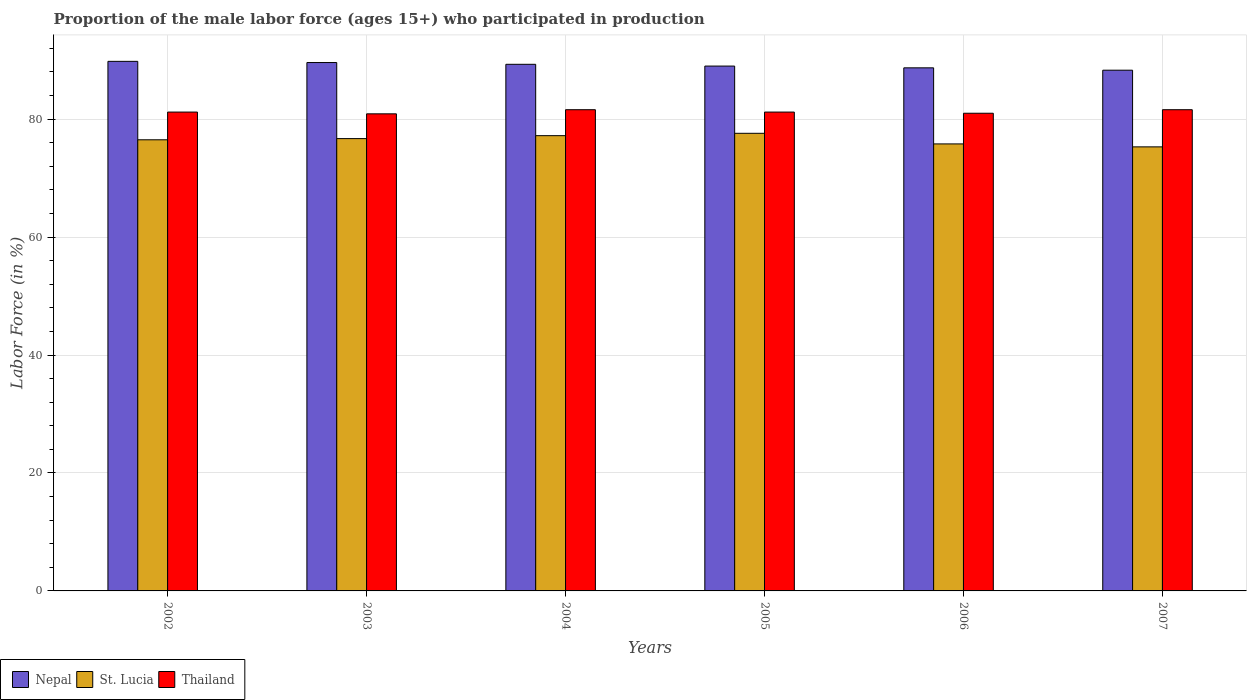How many bars are there on the 4th tick from the right?
Give a very brief answer. 3. In how many cases, is the number of bars for a given year not equal to the number of legend labels?
Keep it short and to the point. 0. What is the proportion of the male labor force who participated in production in St. Lucia in 2006?
Make the answer very short. 75.8. Across all years, what is the maximum proportion of the male labor force who participated in production in Thailand?
Make the answer very short. 81.6. Across all years, what is the minimum proportion of the male labor force who participated in production in Nepal?
Keep it short and to the point. 88.3. In which year was the proportion of the male labor force who participated in production in Thailand maximum?
Offer a terse response. 2004. What is the total proportion of the male labor force who participated in production in Thailand in the graph?
Keep it short and to the point. 487.5. What is the difference between the proportion of the male labor force who participated in production in St. Lucia in 2004 and that in 2007?
Provide a short and direct response. 1.9. What is the difference between the proportion of the male labor force who participated in production in Thailand in 2003 and the proportion of the male labor force who participated in production in St. Lucia in 2005?
Give a very brief answer. 3.3. What is the average proportion of the male labor force who participated in production in Thailand per year?
Ensure brevity in your answer.  81.25. In the year 2004, what is the difference between the proportion of the male labor force who participated in production in Nepal and proportion of the male labor force who participated in production in St. Lucia?
Your answer should be very brief. 12.1. In how many years, is the proportion of the male labor force who participated in production in Thailand greater than 24 %?
Provide a short and direct response. 6. What is the ratio of the proportion of the male labor force who participated in production in St. Lucia in 2002 to that in 2003?
Provide a succinct answer. 1. Is the proportion of the male labor force who participated in production in Nepal in 2006 less than that in 2007?
Ensure brevity in your answer.  No. What is the difference between the highest and the second highest proportion of the male labor force who participated in production in Thailand?
Your answer should be very brief. 0. What is the difference between the highest and the lowest proportion of the male labor force who participated in production in Thailand?
Provide a short and direct response. 0.7. Is the sum of the proportion of the male labor force who participated in production in Nepal in 2003 and 2004 greater than the maximum proportion of the male labor force who participated in production in St. Lucia across all years?
Provide a short and direct response. Yes. What does the 1st bar from the left in 2003 represents?
Your answer should be very brief. Nepal. What does the 3rd bar from the right in 2005 represents?
Provide a succinct answer. Nepal. Are all the bars in the graph horizontal?
Give a very brief answer. No. What is the difference between two consecutive major ticks on the Y-axis?
Your answer should be very brief. 20. Where does the legend appear in the graph?
Offer a very short reply. Bottom left. What is the title of the graph?
Make the answer very short. Proportion of the male labor force (ages 15+) who participated in production. Does "Spain" appear as one of the legend labels in the graph?
Your answer should be very brief. No. What is the label or title of the Y-axis?
Ensure brevity in your answer.  Labor Force (in %). What is the Labor Force (in %) in Nepal in 2002?
Offer a very short reply. 89.8. What is the Labor Force (in %) of St. Lucia in 2002?
Your answer should be very brief. 76.5. What is the Labor Force (in %) of Thailand in 2002?
Provide a short and direct response. 81.2. What is the Labor Force (in %) of Nepal in 2003?
Keep it short and to the point. 89.6. What is the Labor Force (in %) of St. Lucia in 2003?
Offer a very short reply. 76.7. What is the Labor Force (in %) of Thailand in 2003?
Ensure brevity in your answer.  80.9. What is the Labor Force (in %) in Nepal in 2004?
Ensure brevity in your answer.  89.3. What is the Labor Force (in %) in St. Lucia in 2004?
Provide a short and direct response. 77.2. What is the Labor Force (in %) in Thailand in 2004?
Your answer should be compact. 81.6. What is the Labor Force (in %) in Nepal in 2005?
Your response must be concise. 89. What is the Labor Force (in %) of St. Lucia in 2005?
Provide a short and direct response. 77.6. What is the Labor Force (in %) in Thailand in 2005?
Your answer should be very brief. 81.2. What is the Labor Force (in %) in Nepal in 2006?
Provide a short and direct response. 88.7. What is the Labor Force (in %) in St. Lucia in 2006?
Ensure brevity in your answer.  75.8. What is the Labor Force (in %) of Nepal in 2007?
Your answer should be compact. 88.3. What is the Labor Force (in %) of St. Lucia in 2007?
Keep it short and to the point. 75.3. What is the Labor Force (in %) in Thailand in 2007?
Give a very brief answer. 81.6. Across all years, what is the maximum Labor Force (in %) in Nepal?
Keep it short and to the point. 89.8. Across all years, what is the maximum Labor Force (in %) in St. Lucia?
Your answer should be compact. 77.6. Across all years, what is the maximum Labor Force (in %) of Thailand?
Give a very brief answer. 81.6. Across all years, what is the minimum Labor Force (in %) of Nepal?
Provide a succinct answer. 88.3. Across all years, what is the minimum Labor Force (in %) of St. Lucia?
Your answer should be compact. 75.3. Across all years, what is the minimum Labor Force (in %) of Thailand?
Provide a short and direct response. 80.9. What is the total Labor Force (in %) of Nepal in the graph?
Your response must be concise. 534.7. What is the total Labor Force (in %) of St. Lucia in the graph?
Ensure brevity in your answer.  459.1. What is the total Labor Force (in %) in Thailand in the graph?
Provide a succinct answer. 487.5. What is the difference between the Labor Force (in %) in Nepal in 2002 and that in 2003?
Provide a short and direct response. 0.2. What is the difference between the Labor Force (in %) of Nepal in 2002 and that in 2004?
Offer a very short reply. 0.5. What is the difference between the Labor Force (in %) of Nepal in 2002 and that in 2005?
Your answer should be compact. 0.8. What is the difference between the Labor Force (in %) in Thailand in 2002 and that in 2005?
Ensure brevity in your answer.  0. What is the difference between the Labor Force (in %) in Nepal in 2002 and that in 2007?
Offer a terse response. 1.5. What is the difference between the Labor Force (in %) in St. Lucia in 2002 and that in 2007?
Ensure brevity in your answer.  1.2. What is the difference between the Labor Force (in %) of Nepal in 2003 and that in 2004?
Your answer should be compact. 0.3. What is the difference between the Labor Force (in %) in St. Lucia in 2003 and that in 2004?
Provide a short and direct response. -0.5. What is the difference between the Labor Force (in %) of St. Lucia in 2003 and that in 2005?
Make the answer very short. -0.9. What is the difference between the Labor Force (in %) in Thailand in 2003 and that in 2005?
Your answer should be very brief. -0.3. What is the difference between the Labor Force (in %) of Thailand in 2003 and that in 2006?
Your response must be concise. -0.1. What is the difference between the Labor Force (in %) of Nepal in 2004 and that in 2005?
Offer a very short reply. 0.3. What is the difference between the Labor Force (in %) in Thailand in 2004 and that in 2007?
Offer a terse response. 0. What is the difference between the Labor Force (in %) in Nepal in 2005 and that in 2006?
Give a very brief answer. 0.3. What is the difference between the Labor Force (in %) in Thailand in 2005 and that in 2007?
Your answer should be very brief. -0.4. What is the difference between the Labor Force (in %) of St. Lucia in 2006 and that in 2007?
Ensure brevity in your answer.  0.5. What is the difference between the Labor Force (in %) of Thailand in 2006 and that in 2007?
Ensure brevity in your answer.  -0.6. What is the difference between the Labor Force (in %) of Nepal in 2002 and the Labor Force (in %) of St. Lucia in 2003?
Keep it short and to the point. 13.1. What is the difference between the Labor Force (in %) of Nepal in 2002 and the Labor Force (in %) of St. Lucia in 2004?
Your answer should be very brief. 12.6. What is the difference between the Labor Force (in %) in St. Lucia in 2002 and the Labor Force (in %) in Thailand in 2004?
Offer a terse response. -5.1. What is the difference between the Labor Force (in %) of Nepal in 2002 and the Labor Force (in %) of St. Lucia in 2005?
Give a very brief answer. 12.2. What is the difference between the Labor Force (in %) in Nepal in 2002 and the Labor Force (in %) in Thailand in 2005?
Your answer should be very brief. 8.6. What is the difference between the Labor Force (in %) in St. Lucia in 2002 and the Labor Force (in %) in Thailand in 2005?
Ensure brevity in your answer.  -4.7. What is the difference between the Labor Force (in %) in St. Lucia in 2002 and the Labor Force (in %) in Thailand in 2006?
Give a very brief answer. -4.5. What is the difference between the Labor Force (in %) in St. Lucia in 2002 and the Labor Force (in %) in Thailand in 2007?
Give a very brief answer. -5.1. What is the difference between the Labor Force (in %) of St. Lucia in 2003 and the Labor Force (in %) of Thailand in 2004?
Ensure brevity in your answer.  -4.9. What is the difference between the Labor Force (in %) of Nepal in 2003 and the Labor Force (in %) of St. Lucia in 2005?
Ensure brevity in your answer.  12. What is the difference between the Labor Force (in %) of Nepal in 2003 and the Labor Force (in %) of Thailand in 2005?
Give a very brief answer. 8.4. What is the difference between the Labor Force (in %) of St. Lucia in 2003 and the Labor Force (in %) of Thailand in 2006?
Your answer should be very brief. -4.3. What is the difference between the Labor Force (in %) in Nepal in 2003 and the Labor Force (in %) in St. Lucia in 2007?
Provide a short and direct response. 14.3. What is the difference between the Labor Force (in %) of St. Lucia in 2003 and the Labor Force (in %) of Thailand in 2007?
Make the answer very short. -4.9. What is the difference between the Labor Force (in %) of Nepal in 2004 and the Labor Force (in %) of St. Lucia in 2005?
Offer a very short reply. 11.7. What is the difference between the Labor Force (in %) of St. Lucia in 2004 and the Labor Force (in %) of Thailand in 2005?
Your answer should be very brief. -4. What is the difference between the Labor Force (in %) of Nepal in 2004 and the Labor Force (in %) of St. Lucia in 2006?
Your answer should be very brief. 13.5. What is the difference between the Labor Force (in %) in Nepal in 2004 and the Labor Force (in %) in Thailand in 2006?
Your answer should be very brief. 8.3. What is the difference between the Labor Force (in %) in Nepal in 2004 and the Labor Force (in %) in Thailand in 2007?
Give a very brief answer. 7.7. What is the difference between the Labor Force (in %) in St. Lucia in 2004 and the Labor Force (in %) in Thailand in 2007?
Give a very brief answer. -4.4. What is the difference between the Labor Force (in %) in Nepal in 2005 and the Labor Force (in %) in St. Lucia in 2007?
Ensure brevity in your answer.  13.7. What is the difference between the Labor Force (in %) in St. Lucia in 2005 and the Labor Force (in %) in Thailand in 2007?
Your answer should be very brief. -4. What is the difference between the Labor Force (in %) in St. Lucia in 2006 and the Labor Force (in %) in Thailand in 2007?
Keep it short and to the point. -5.8. What is the average Labor Force (in %) in Nepal per year?
Your answer should be very brief. 89.12. What is the average Labor Force (in %) in St. Lucia per year?
Provide a short and direct response. 76.52. What is the average Labor Force (in %) of Thailand per year?
Keep it short and to the point. 81.25. In the year 2003, what is the difference between the Labor Force (in %) in Nepal and Labor Force (in %) in Thailand?
Give a very brief answer. 8.7. In the year 2004, what is the difference between the Labor Force (in %) of Nepal and Labor Force (in %) of St. Lucia?
Offer a terse response. 12.1. In the year 2005, what is the difference between the Labor Force (in %) in Nepal and Labor Force (in %) in St. Lucia?
Make the answer very short. 11.4. In the year 2006, what is the difference between the Labor Force (in %) of Nepal and Labor Force (in %) of St. Lucia?
Provide a short and direct response. 12.9. In the year 2006, what is the difference between the Labor Force (in %) of Nepal and Labor Force (in %) of Thailand?
Give a very brief answer. 7.7. In the year 2006, what is the difference between the Labor Force (in %) in St. Lucia and Labor Force (in %) in Thailand?
Make the answer very short. -5.2. In the year 2007, what is the difference between the Labor Force (in %) of Nepal and Labor Force (in %) of St. Lucia?
Offer a terse response. 13. In the year 2007, what is the difference between the Labor Force (in %) in Nepal and Labor Force (in %) in Thailand?
Make the answer very short. 6.7. In the year 2007, what is the difference between the Labor Force (in %) in St. Lucia and Labor Force (in %) in Thailand?
Keep it short and to the point. -6.3. What is the ratio of the Labor Force (in %) in Nepal in 2002 to that in 2003?
Your answer should be compact. 1. What is the ratio of the Labor Force (in %) of Nepal in 2002 to that in 2004?
Provide a succinct answer. 1.01. What is the ratio of the Labor Force (in %) in St. Lucia in 2002 to that in 2004?
Your answer should be compact. 0.99. What is the ratio of the Labor Force (in %) of Thailand in 2002 to that in 2004?
Make the answer very short. 1. What is the ratio of the Labor Force (in %) in St. Lucia in 2002 to that in 2005?
Offer a terse response. 0.99. What is the ratio of the Labor Force (in %) in Nepal in 2002 to that in 2006?
Make the answer very short. 1.01. What is the ratio of the Labor Force (in %) of St. Lucia in 2002 to that in 2006?
Make the answer very short. 1.01. What is the ratio of the Labor Force (in %) in Nepal in 2002 to that in 2007?
Your answer should be very brief. 1.02. What is the ratio of the Labor Force (in %) in St. Lucia in 2002 to that in 2007?
Ensure brevity in your answer.  1.02. What is the ratio of the Labor Force (in %) in Nepal in 2003 to that in 2004?
Make the answer very short. 1. What is the ratio of the Labor Force (in %) in Nepal in 2003 to that in 2005?
Make the answer very short. 1.01. What is the ratio of the Labor Force (in %) of St. Lucia in 2003 to that in 2005?
Your response must be concise. 0.99. What is the ratio of the Labor Force (in %) in Nepal in 2003 to that in 2006?
Your response must be concise. 1.01. What is the ratio of the Labor Force (in %) in St. Lucia in 2003 to that in 2006?
Your answer should be very brief. 1.01. What is the ratio of the Labor Force (in %) of Nepal in 2003 to that in 2007?
Provide a short and direct response. 1.01. What is the ratio of the Labor Force (in %) of St. Lucia in 2003 to that in 2007?
Ensure brevity in your answer.  1.02. What is the ratio of the Labor Force (in %) of Thailand in 2003 to that in 2007?
Provide a short and direct response. 0.99. What is the ratio of the Labor Force (in %) of Nepal in 2004 to that in 2005?
Offer a terse response. 1. What is the ratio of the Labor Force (in %) in St. Lucia in 2004 to that in 2005?
Offer a very short reply. 0.99. What is the ratio of the Labor Force (in %) in Nepal in 2004 to that in 2006?
Ensure brevity in your answer.  1.01. What is the ratio of the Labor Force (in %) in St. Lucia in 2004 to that in 2006?
Your response must be concise. 1.02. What is the ratio of the Labor Force (in %) in Thailand in 2004 to that in 2006?
Your answer should be very brief. 1.01. What is the ratio of the Labor Force (in %) in Nepal in 2004 to that in 2007?
Make the answer very short. 1.01. What is the ratio of the Labor Force (in %) of St. Lucia in 2004 to that in 2007?
Offer a very short reply. 1.03. What is the ratio of the Labor Force (in %) in Thailand in 2004 to that in 2007?
Offer a terse response. 1. What is the ratio of the Labor Force (in %) in St. Lucia in 2005 to that in 2006?
Your answer should be very brief. 1.02. What is the ratio of the Labor Force (in %) in Thailand in 2005 to that in 2006?
Offer a very short reply. 1. What is the ratio of the Labor Force (in %) in Nepal in 2005 to that in 2007?
Provide a succinct answer. 1.01. What is the ratio of the Labor Force (in %) of St. Lucia in 2005 to that in 2007?
Make the answer very short. 1.03. What is the ratio of the Labor Force (in %) in Thailand in 2005 to that in 2007?
Your response must be concise. 1. What is the ratio of the Labor Force (in %) in Nepal in 2006 to that in 2007?
Ensure brevity in your answer.  1. What is the ratio of the Labor Force (in %) in St. Lucia in 2006 to that in 2007?
Provide a short and direct response. 1.01. What is the difference between the highest and the second highest Labor Force (in %) in Nepal?
Your response must be concise. 0.2. What is the difference between the highest and the second highest Labor Force (in %) in Thailand?
Provide a short and direct response. 0. What is the difference between the highest and the lowest Labor Force (in %) of Nepal?
Give a very brief answer. 1.5. What is the difference between the highest and the lowest Labor Force (in %) of St. Lucia?
Give a very brief answer. 2.3. 